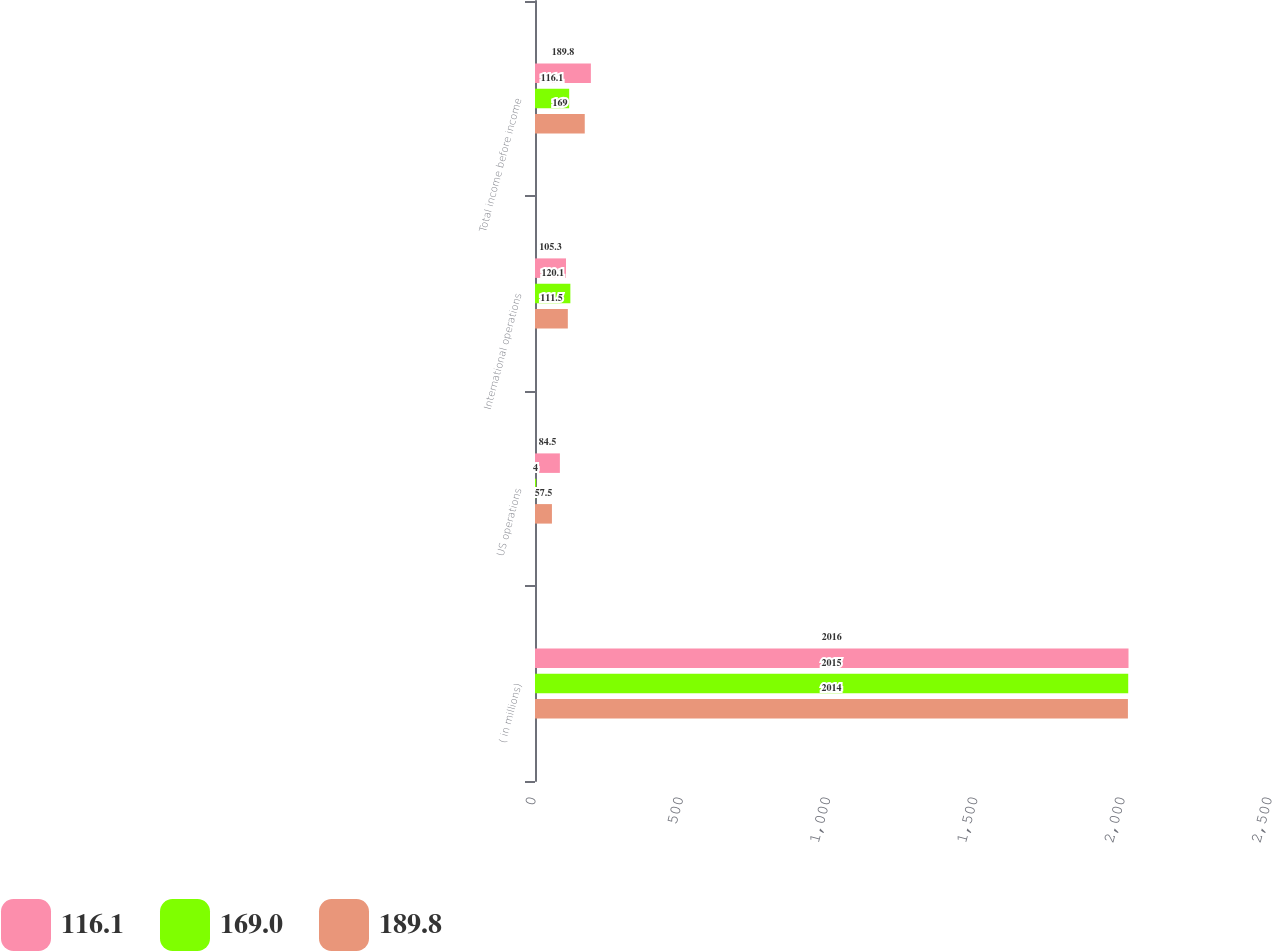Convert chart to OTSL. <chart><loc_0><loc_0><loc_500><loc_500><stacked_bar_chart><ecel><fcel>( in millions)<fcel>US operations<fcel>International operations<fcel>Total income before income<nl><fcel>116.1<fcel>2016<fcel>84.5<fcel>105.3<fcel>189.8<nl><fcel>169<fcel>2015<fcel>4<fcel>120.1<fcel>116.1<nl><fcel>189.8<fcel>2014<fcel>57.5<fcel>111.5<fcel>169<nl></chart> 